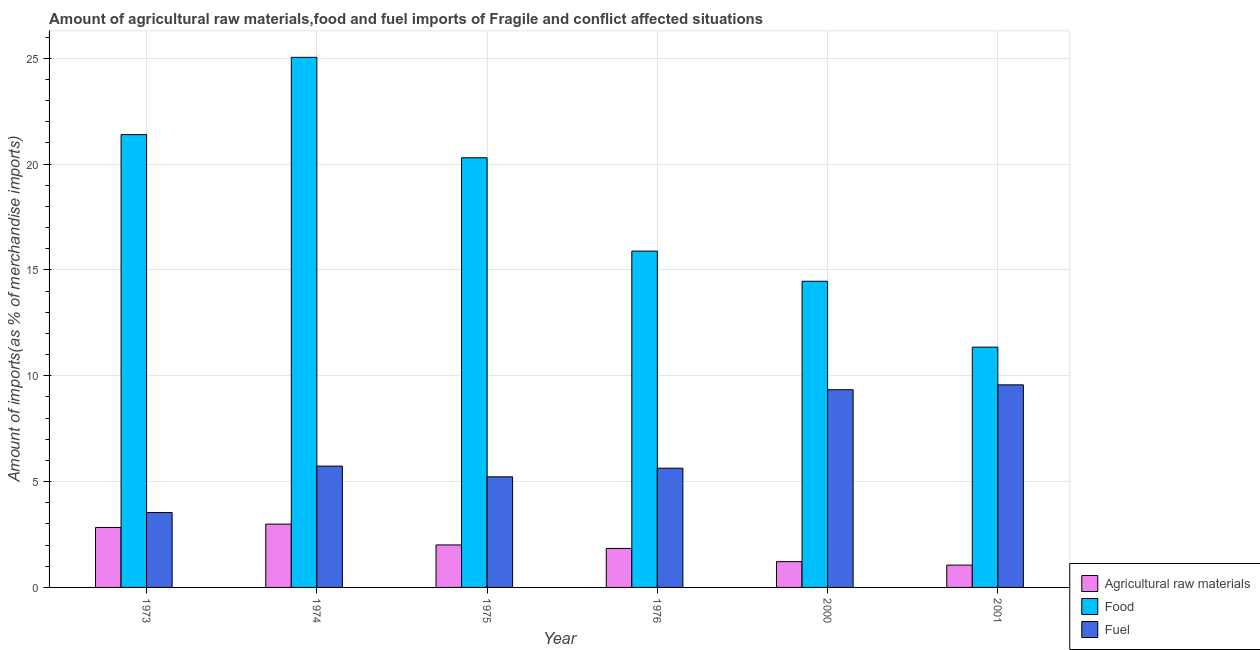Are the number of bars per tick equal to the number of legend labels?
Offer a terse response. Yes. How many bars are there on the 6th tick from the left?
Offer a very short reply. 3. How many bars are there on the 2nd tick from the right?
Your answer should be very brief. 3. What is the percentage of fuel imports in 1976?
Your answer should be compact. 5.63. Across all years, what is the maximum percentage of fuel imports?
Offer a terse response. 9.57. Across all years, what is the minimum percentage of food imports?
Offer a very short reply. 11.35. In which year was the percentage of food imports maximum?
Ensure brevity in your answer.  1974. What is the total percentage of raw materials imports in the graph?
Your answer should be very brief. 11.94. What is the difference between the percentage of fuel imports in 1976 and that in 2000?
Your response must be concise. -3.71. What is the difference between the percentage of food imports in 2000 and the percentage of raw materials imports in 1974?
Give a very brief answer. -10.58. What is the average percentage of food imports per year?
Offer a terse response. 18.07. In the year 1974, what is the difference between the percentage of fuel imports and percentage of food imports?
Keep it short and to the point. 0. In how many years, is the percentage of fuel imports greater than 13 %?
Provide a succinct answer. 0. What is the ratio of the percentage of fuel imports in 1974 to that in 2000?
Ensure brevity in your answer.  0.61. Is the percentage of fuel imports in 1976 less than that in 2000?
Offer a very short reply. Yes. Is the difference between the percentage of fuel imports in 1974 and 2000 greater than the difference between the percentage of raw materials imports in 1974 and 2000?
Ensure brevity in your answer.  No. What is the difference between the highest and the second highest percentage of raw materials imports?
Offer a very short reply. 0.16. What is the difference between the highest and the lowest percentage of raw materials imports?
Provide a succinct answer. 1.94. Is the sum of the percentage of food imports in 1973 and 1976 greater than the maximum percentage of fuel imports across all years?
Offer a terse response. Yes. What does the 1st bar from the left in 1975 represents?
Give a very brief answer. Agricultural raw materials. What does the 1st bar from the right in 1974 represents?
Your response must be concise. Fuel. How many bars are there?
Your answer should be very brief. 18. How many years are there in the graph?
Your answer should be compact. 6. What is the difference between two consecutive major ticks on the Y-axis?
Offer a very short reply. 5. Are the values on the major ticks of Y-axis written in scientific E-notation?
Your answer should be very brief. No. Does the graph contain grids?
Ensure brevity in your answer.  Yes. Where does the legend appear in the graph?
Give a very brief answer. Bottom right. How many legend labels are there?
Provide a succinct answer. 3. How are the legend labels stacked?
Give a very brief answer. Vertical. What is the title of the graph?
Provide a succinct answer. Amount of agricultural raw materials,food and fuel imports of Fragile and conflict affected situations. What is the label or title of the X-axis?
Give a very brief answer. Year. What is the label or title of the Y-axis?
Provide a succinct answer. Amount of imports(as % of merchandise imports). What is the Amount of imports(as % of merchandise imports) in Agricultural raw materials in 1973?
Ensure brevity in your answer.  2.83. What is the Amount of imports(as % of merchandise imports) in Food in 1973?
Give a very brief answer. 21.39. What is the Amount of imports(as % of merchandise imports) in Fuel in 1973?
Give a very brief answer. 3.54. What is the Amount of imports(as % of merchandise imports) in Agricultural raw materials in 1974?
Your response must be concise. 2.99. What is the Amount of imports(as % of merchandise imports) in Food in 1974?
Your response must be concise. 25.04. What is the Amount of imports(as % of merchandise imports) in Fuel in 1974?
Keep it short and to the point. 5.73. What is the Amount of imports(as % of merchandise imports) in Agricultural raw materials in 1975?
Offer a very short reply. 2.01. What is the Amount of imports(as % of merchandise imports) in Food in 1975?
Offer a very short reply. 20.3. What is the Amount of imports(as % of merchandise imports) in Fuel in 1975?
Offer a terse response. 5.22. What is the Amount of imports(as % of merchandise imports) of Agricultural raw materials in 1976?
Offer a terse response. 1.84. What is the Amount of imports(as % of merchandise imports) in Food in 1976?
Offer a very short reply. 15.89. What is the Amount of imports(as % of merchandise imports) of Fuel in 1976?
Provide a succinct answer. 5.63. What is the Amount of imports(as % of merchandise imports) in Agricultural raw materials in 2000?
Your answer should be compact. 1.22. What is the Amount of imports(as % of merchandise imports) of Food in 2000?
Make the answer very short. 14.46. What is the Amount of imports(as % of merchandise imports) in Fuel in 2000?
Offer a terse response. 9.34. What is the Amount of imports(as % of merchandise imports) of Agricultural raw materials in 2001?
Give a very brief answer. 1.05. What is the Amount of imports(as % of merchandise imports) in Food in 2001?
Keep it short and to the point. 11.35. What is the Amount of imports(as % of merchandise imports) in Fuel in 2001?
Provide a short and direct response. 9.57. Across all years, what is the maximum Amount of imports(as % of merchandise imports) of Agricultural raw materials?
Your answer should be compact. 2.99. Across all years, what is the maximum Amount of imports(as % of merchandise imports) of Food?
Give a very brief answer. 25.04. Across all years, what is the maximum Amount of imports(as % of merchandise imports) of Fuel?
Your answer should be compact. 9.57. Across all years, what is the minimum Amount of imports(as % of merchandise imports) in Agricultural raw materials?
Provide a short and direct response. 1.05. Across all years, what is the minimum Amount of imports(as % of merchandise imports) of Food?
Keep it short and to the point. 11.35. Across all years, what is the minimum Amount of imports(as % of merchandise imports) in Fuel?
Provide a short and direct response. 3.54. What is the total Amount of imports(as % of merchandise imports) of Agricultural raw materials in the graph?
Your answer should be compact. 11.94. What is the total Amount of imports(as % of merchandise imports) in Food in the graph?
Your answer should be very brief. 108.43. What is the total Amount of imports(as % of merchandise imports) in Fuel in the graph?
Make the answer very short. 39.04. What is the difference between the Amount of imports(as % of merchandise imports) of Agricultural raw materials in 1973 and that in 1974?
Provide a succinct answer. -0.16. What is the difference between the Amount of imports(as % of merchandise imports) of Food in 1973 and that in 1974?
Provide a short and direct response. -3.65. What is the difference between the Amount of imports(as % of merchandise imports) in Fuel in 1973 and that in 1974?
Keep it short and to the point. -2.19. What is the difference between the Amount of imports(as % of merchandise imports) of Agricultural raw materials in 1973 and that in 1975?
Your response must be concise. 0.83. What is the difference between the Amount of imports(as % of merchandise imports) of Food in 1973 and that in 1975?
Make the answer very short. 1.09. What is the difference between the Amount of imports(as % of merchandise imports) in Fuel in 1973 and that in 1975?
Your response must be concise. -1.69. What is the difference between the Amount of imports(as % of merchandise imports) in Food in 1973 and that in 1976?
Offer a terse response. 5.5. What is the difference between the Amount of imports(as % of merchandise imports) in Fuel in 1973 and that in 1976?
Offer a terse response. -2.09. What is the difference between the Amount of imports(as % of merchandise imports) of Agricultural raw materials in 1973 and that in 2000?
Your response must be concise. 1.62. What is the difference between the Amount of imports(as % of merchandise imports) in Food in 1973 and that in 2000?
Provide a short and direct response. 6.93. What is the difference between the Amount of imports(as % of merchandise imports) in Fuel in 1973 and that in 2000?
Offer a terse response. -5.8. What is the difference between the Amount of imports(as % of merchandise imports) of Agricultural raw materials in 1973 and that in 2001?
Provide a succinct answer. 1.78. What is the difference between the Amount of imports(as % of merchandise imports) of Food in 1973 and that in 2001?
Keep it short and to the point. 10.04. What is the difference between the Amount of imports(as % of merchandise imports) in Fuel in 1973 and that in 2001?
Ensure brevity in your answer.  -6.03. What is the difference between the Amount of imports(as % of merchandise imports) in Food in 1974 and that in 1975?
Offer a terse response. 4.74. What is the difference between the Amount of imports(as % of merchandise imports) of Fuel in 1974 and that in 1975?
Your response must be concise. 0.51. What is the difference between the Amount of imports(as % of merchandise imports) in Agricultural raw materials in 1974 and that in 1976?
Provide a short and direct response. 1.15. What is the difference between the Amount of imports(as % of merchandise imports) of Food in 1974 and that in 1976?
Make the answer very short. 9.15. What is the difference between the Amount of imports(as % of merchandise imports) of Fuel in 1974 and that in 1976?
Your response must be concise. 0.1. What is the difference between the Amount of imports(as % of merchandise imports) in Agricultural raw materials in 1974 and that in 2000?
Provide a short and direct response. 1.77. What is the difference between the Amount of imports(as % of merchandise imports) of Food in 1974 and that in 2000?
Keep it short and to the point. 10.58. What is the difference between the Amount of imports(as % of merchandise imports) of Fuel in 1974 and that in 2000?
Your answer should be very brief. -3.61. What is the difference between the Amount of imports(as % of merchandise imports) of Agricultural raw materials in 1974 and that in 2001?
Provide a succinct answer. 1.94. What is the difference between the Amount of imports(as % of merchandise imports) in Food in 1974 and that in 2001?
Provide a succinct answer. 13.69. What is the difference between the Amount of imports(as % of merchandise imports) in Fuel in 1974 and that in 2001?
Make the answer very short. -3.84. What is the difference between the Amount of imports(as % of merchandise imports) of Agricultural raw materials in 1975 and that in 1976?
Provide a succinct answer. 0.17. What is the difference between the Amount of imports(as % of merchandise imports) of Food in 1975 and that in 1976?
Offer a terse response. 4.41. What is the difference between the Amount of imports(as % of merchandise imports) of Fuel in 1975 and that in 1976?
Provide a short and direct response. -0.41. What is the difference between the Amount of imports(as % of merchandise imports) in Agricultural raw materials in 1975 and that in 2000?
Your response must be concise. 0.79. What is the difference between the Amount of imports(as % of merchandise imports) of Food in 1975 and that in 2000?
Keep it short and to the point. 5.83. What is the difference between the Amount of imports(as % of merchandise imports) of Fuel in 1975 and that in 2000?
Your response must be concise. -4.12. What is the difference between the Amount of imports(as % of merchandise imports) in Agricultural raw materials in 1975 and that in 2001?
Give a very brief answer. 0.95. What is the difference between the Amount of imports(as % of merchandise imports) of Food in 1975 and that in 2001?
Provide a short and direct response. 8.95. What is the difference between the Amount of imports(as % of merchandise imports) in Fuel in 1975 and that in 2001?
Offer a very short reply. -4.35. What is the difference between the Amount of imports(as % of merchandise imports) in Agricultural raw materials in 1976 and that in 2000?
Keep it short and to the point. 0.62. What is the difference between the Amount of imports(as % of merchandise imports) in Food in 1976 and that in 2000?
Offer a terse response. 1.43. What is the difference between the Amount of imports(as % of merchandise imports) of Fuel in 1976 and that in 2000?
Your answer should be compact. -3.71. What is the difference between the Amount of imports(as % of merchandise imports) in Agricultural raw materials in 1976 and that in 2001?
Offer a terse response. 0.79. What is the difference between the Amount of imports(as % of merchandise imports) of Food in 1976 and that in 2001?
Offer a very short reply. 4.54. What is the difference between the Amount of imports(as % of merchandise imports) in Fuel in 1976 and that in 2001?
Provide a succinct answer. -3.94. What is the difference between the Amount of imports(as % of merchandise imports) of Agricultural raw materials in 2000 and that in 2001?
Provide a short and direct response. 0.16. What is the difference between the Amount of imports(as % of merchandise imports) in Food in 2000 and that in 2001?
Your answer should be compact. 3.11. What is the difference between the Amount of imports(as % of merchandise imports) of Fuel in 2000 and that in 2001?
Provide a short and direct response. -0.23. What is the difference between the Amount of imports(as % of merchandise imports) in Agricultural raw materials in 1973 and the Amount of imports(as % of merchandise imports) in Food in 1974?
Your answer should be compact. -22.21. What is the difference between the Amount of imports(as % of merchandise imports) of Agricultural raw materials in 1973 and the Amount of imports(as % of merchandise imports) of Fuel in 1974?
Keep it short and to the point. -2.9. What is the difference between the Amount of imports(as % of merchandise imports) in Food in 1973 and the Amount of imports(as % of merchandise imports) in Fuel in 1974?
Provide a succinct answer. 15.66. What is the difference between the Amount of imports(as % of merchandise imports) in Agricultural raw materials in 1973 and the Amount of imports(as % of merchandise imports) in Food in 1975?
Give a very brief answer. -17.46. What is the difference between the Amount of imports(as % of merchandise imports) in Agricultural raw materials in 1973 and the Amount of imports(as % of merchandise imports) in Fuel in 1975?
Your answer should be very brief. -2.39. What is the difference between the Amount of imports(as % of merchandise imports) of Food in 1973 and the Amount of imports(as % of merchandise imports) of Fuel in 1975?
Keep it short and to the point. 16.17. What is the difference between the Amount of imports(as % of merchandise imports) in Agricultural raw materials in 1973 and the Amount of imports(as % of merchandise imports) in Food in 1976?
Your response must be concise. -13.05. What is the difference between the Amount of imports(as % of merchandise imports) in Agricultural raw materials in 1973 and the Amount of imports(as % of merchandise imports) in Fuel in 1976?
Offer a terse response. -2.8. What is the difference between the Amount of imports(as % of merchandise imports) of Food in 1973 and the Amount of imports(as % of merchandise imports) of Fuel in 1976?
Your answer should be very brief. 15.76. What is the difference between the Amount of imports(as % of merchandise imports) of Agricultural raw materials in 1973 and the Amount of imports(as % of merchandise imports) of Food in 2000?
Your answer should be compact. -11.63. What is the difference between the Amount of imports(as % of merchandise imports) in Agricultural raw materials in 1973 and the Amount of imports(as % of merchandise imports) in Fuel in 2000?
Give a very brief answer. -6.51. What is the difference between the Amount of imports(as % of merchandise imports) in Food in 1973 and the Amount of imports(as % of merchandise imports) in Fuel in 2000?
Your response must be concise. 12.05. What is the difference between the Amount of imports(as % of merchandise imports) in Agricultural raw materials in 1973 and the Amount of imports(as % of merchandise imports) in Food in 2001?
Your answer should be compact. -8.52. What is the difference between the Amount of imports(as % of merchandise imports) of Agricultural raw materials in 1973 and the Amount of imports(as % of merchandise imports) of Fuel in 2001?
Offer a very short reply. -6.74. What is the difference between the Amount of imports(as % of merchandise imports) of Food in 1973 and the Amount of imports(as % of merchandise imports) of Fuel in 2001?
Provide a succinct answer. 11.82. What is the difference between the Amount of imports(as % of merchandise imports) in Agricultural raw materials in 1974 and the Amount of imports(as % of merchandise imports) in Food in 1975?
Provide a short and direct response. -17.31. What is the difference between the Amount of imports(as % of merchandise imports) of Agricultural raw materials in 1974 and the Amount of imports(as % of merchandise imports) of Fuel in 1975?
Offer a terse response. -2.23. What is the difference between the Amount of imports(as % of merchandise imports) of Food in 1974 and the Amount of imports(as % of merchandise imports) of Fuel in 1975?
Make the answer very short. 19.82. What is the difference between the Amount of imports(as % of merchandise imports) in Agricultural raw materials in 1974 and the Amount of imports(as % of merchandise imports) in Food in 1976?
Your answer should be compact. -12.9. What is the difference between the Amount of imports(as % of merchandise imports) of Agricultural raw materials in 1974 and the Amount of imports(as % of merchandise imports) of Fuel in 1976?
Offer a very short reply. -2.64. What is the difference between the Amount of imports(as % of merchandise imports) of Food in 1974 and the Amount of imports(as % of merchandise imports) of Fuel in 1976?
Provide a succinct answer. 19.41. What is the difference between the Amount of imports(as % of merchandise imports) in Agricultural raw materials in 1974 and the Amount of imports(as % of merchandise imports) in Food in 2000?
Provide a succinct answer. -11.47. What is the difference between the Amount of imports(as % of merchandise imports) in Agricultural raw materials in 1974 and the Amount of imports(as % of merchandise imports) in Fuel in 2000?
Ensure brevity in your answer.  -6.35. What is the difference between the Amount of imports(as % of merchandise imports) of Food in 1974 and the Amount of imports(as % of merchandise imports) of Fuel in 2000?
Ensure brevity in your answer.  15.7. What is the difference between the Amount of imports(as % of merchandise imports) of Agricultural raw materials in 1974 and the Amount of imports(as % of merchandise imports) of Food in 2001?
Keep it short and to the point. -8.36. What is the difference between the Amount of imports(as % of merchandise imports) of Agricultural raw materials in 1974 and the Amount of imports(as % of merchandise imports) of Fuel in 2001?
Ensure brevity in your answer.  -6.58. What is the difference between the Amount of imports(as % of merchandise imports) of Food in 1974 and the Amount of imports(as % of merchandise imports) of Fuel in 2001?
Offer a very short reply. 15.47. What is the difference between the Amount of imports(as % of merchandise imports) in Agricultural raw materials in 1975 and the Amount of imports(as % of merchandise imports) in Food in 1976?
Provide a short and direct response. -13.88. What is the difference between the Amount of imports(as % of merchandise imports) of Agricultural raw materials in 1975 and the Amount of imports(as % of merchandise imports) of Fuel in 1976?
Your answer should be compact. -3.63. What is the difference between the Amount of imports(as % of merchandise imports) in Food in 1975 and the Amount of imports(as % of merchandise imports) in Fuel in 1976?
Offer a terse response. 14.66. What is the difference between the Amount of imports(as % of merchandise imports) in Agricultural raw materials in 1975 and the Amount of imports(as % of merchandise imports) in Food in 2000?
Ensure brevity in your answer.  -12.45. What is the difference between the Amount of imports(as % of merchandise imports) in Agricultural raw materials in 1975 and the Amount of imports(as % of merchandise imports) in Fuel in 2000?
Make the answer very short. -7.33. What is the difference between the Amount of imports(as % of merchandise imports) of Food in 1975 and the Amount of imports(as % of merchandise imports) of Fuel in 2000?
Keep it short and to the point. 10.96. What is the difference between the Amount of imports(as % of merchandise imports) of Agricultural raw materials in 1975 and the Amount of imports(as % of merchandise imports) of Food in 2001?
Ensure brevity in your answer.  -9.34. What is the difference between the Amount of imports(as % of merchandise imports) in Agricultural raw materials in 1975 and the Amount of imports(as % of merchandise imports) in Fuel in 2001?
Provide a short and direct response. -7.56. What is the difference between the Amount of imports(as % of merchandise imports) in Food in 1975 and the Amount of imports(as % of merchandise imports) in Fuel in 2001?
Make the answer very short. 10.73. What is the difference between the Amount of imports(as % of merchandise imports) in Agricultural raw materials in 1976 and the Amount of imports(as % of merchandise imports) in Food in 2000?
Provide a succinct answer. -12.62. What is the difference between the Amount of imports(as % of merchandise imports) in Agricultural raw materials in 1976 and the Amount of imports(as % of merchandise imports) in Fuel in 2000?
Offer a terse response. -7.5. What is the difference between the Amount of imports(as % of merchandise imports) in Food in 1976 and the Amount of imports(as % of merchandise imports) in Fuel in 2000?
Keep it short and to the point. 6.55. What is the difference between the Amount of imports(as % of merchandise imports) in Agricultural raw materials in 1976 and the Amount of imports(as % of merchandise imports) in Food in 2001?
Ensure brevity in your answer.  -9.51. What is the difference between the Amount of imports(as % of merchandise imports) in Agricultural raw materials in 1976 and the Amount of imports(as % of merchandise imports) in Fuel in 2001?
Keep it short and to the point. -7.73. What is the difference between the Amount of imports(as % of merchandise imports) of Food in 1976 and the Amount of imports(as % of merchandise imports) of Fuel in 2001?
Your answer should be very brief. 6.32. What is the difference between the Amount of imports(as % of merchandise imports) of Agricultural raw materials in 2000 and the Amount of imports(as % of merchandise imports) of Food in 2001?
Offer a very short reply. -10.13. What is the difference between the Amount of imports(as % of merchandise imports) of Agricultural raw materials in 2000 and the Amount of imports(as % of merchandise imports) of Fuel in 2001?
Offer a very short reply. -8.35. What is the difference between the Amount of imports(as % of merchandise imports) of Food in 2000 and the Amount of imports(as % of merchandise imports) of Fuel in 2001?
Your answer should be very brief. 4.89. What is the average Amount of imports(as % of merchandise imports) of Agricultural raw materials per year?
Your response must be concise. 1.99. What is the average Amount of imports(as % of merchandise imports) in Food per year?
Your response must be concise. 18.07. What is the average Amount of imports(as % of merchandise imports) of Fuel per year?
Make the answer very short. 6.51. In the year 1973, what is the difference between the Amount of imports(as % of merchandise imports) of Agricultural raw materials and Amount of imports(as % of merchandise imports) of Food?
Provide a succinct answer. -18.56. In the year 1973, what is the difference between the Amount of imports(as % of merchandise imports) of Agricultural raw materials and Amount of imports(as % of merchandise imports) of Fuel?
Offer a very short reply. -0.71. In the year 1973, what is the difference between the Amount of imports(as % of merchandise imports) in Food and Amount of imports(as % of merchandise imports) in Fuel?
Offer a very short reply. 17.85. In the year 1974, what is the difference between the Amount of imports(as % of merchandise imports) of Agricultural raw materials and Amount of imports(as % of merchandise imports) of Food?
Your response must be concise. -22.05. In the year 1974, what is the difference between the Amount of imports(as % of merchandise imports) in Agricultural raw materials and Amount of imports(as % of merchandise imports) in Fuel?
Your answer should be compact. -2.74. In the year 1974, what is the difference between the Amount of imports(as % of merchandise imports) of Food and Amount of imports(as % of merchandise imports) of Fuel?
Keep it short and to the point. 19.31. In the year 1975, what is the difference between the Amount of imports(as % of merchandise imports) of Agricultural raw materials and Amount of imports(as % of merchandise imports) of Food?
Give a very brief answer. -18.29. In the year 1975, what is the difference between the Amount of imports(as % of merchandise imports) of Agricultural raw materials and Amount of imports(as % of merchandise imports) of Fuel?
Provide a succinct answer. -3.22. In the year 1975, what is the difference between the Amount of imports(as % of merchandise imports) in Food and Amount of imports(as % of merchandise imports) in Fuel?
Offer a very short reply. 15.07. In the year 1976, what is the difference between the Amount of imports(as % of merchandise imports) in Agricultural raw materials and Amount of imports(as % of merchandise imports) in Food?
Your response must be concise. -14.05. In the year 1976, what is the difference between the Amount of imports(as % of merchandise imports) in Agricultural raw materials and Amount of imports(as % of merchandise imports) in Fuel?
Offer a very short reply. -3.79. In the year 1976, what is the difference between the Amount of imports(as % of merchandise imports) in Food and Amount of imports(as % of merchandise imports) in Fuel?
Your answer should be compact. 10.25. In the year 2000, what is the difference between the Amount of imports(as % of merchandise imports) of Agricultural raw materials and Amount of imports(as % of merchandise imports) of Food?
Your answer should be compact. -13.24. In the year 2000, what is the difference between the Amount of imports(as % of merchandise imports) in Agricultural raw materials and Amount of imports(as % of merchandise imports) in Fuel?
Give a very brief answer. -8.12. In the year 2000, what is the difference between the Amount of imports(as % of merchandise imports) in Food and Amount of imports(as % of merchandise imports) in Fuel?
Provide a succinct answer. 5.12. In the year 2001, what is the difference between the Amount of imports(as % of merchandise imports) in Agricultural raw materials and Amount of imports(as % of merchandise imports) in Food?
Ensure brevity in your answer.  -10.3. In the year 2001, what is the difference between the Amount of imports(as % of merchandise imports) in Agricultural raw materials and Amount of imports(as % of merchandise imports) in Fuel?
Offer a terse response. -8.52. In the year 2001, what is the difference between the Amount of imports(as % of merchandise imports) in Food and Amount of imports(as % of merchandise imports) in Fuel?
Make the answer very short. 1.78. What is the ratio of the Amount of imports(as % of merchandise imports) of Agricultural raw materials in 1973 to that in 1974?
Your answer should be very brief. 0.95. What is the ratio of the Amount of imports(as % of merchandise imports) in Food in 1973 to that in 1974?
Provide a succinct answer. 0.85. What is the ratio of the Amount of imports(as % of merchandise imports) in Fuel in 1973 to that in 1974?
Provide a short and direct response. 0.62. What is the ratio of the Amount of imports(as % of merchandise imports) in Agricultural raw materials in 1973 to that in 1975?
Your response must be concise. 1.41. What is the ratio of the Amount of imports(as % of merchandise imports) in Food in 1973 to that in 1975?
Give a very brief answer. 1.05. What is the ratio of the Amount of imports(as % of merchandise imports) of Fuel in 1973 to that in 1975?
Provide a succinct answer. 0.68. What is the ratio of the Amount of imports(as % of merchandise imports) of Agricultural raw materials in 1973 to that in 1976?
Offer a very short reply. 1.54. What is the ratio of the Amount of imports(as % of merchandise imports) in Food in 1973 to that in 1976?
Offer a very short reply. 1.35. What is the ratio of the Amount of imports(as % of merchandise imports) in Fuel in 1973 to that in 1976?
Your answer should be very brief. 0.63. What is the ratio of the Amount of imports(as % of merchandise imports) of Agricultural raw materials in 1973 to that in 2000?
Keep it short and to the point. 2.33. What is the ratio of the Amount of imports(as % of merchandise imports) in Food in 1973 to that in 2000?
Your answer should be compact. 1.48. What is the ratio of the Amount of imports(as % of merchandise imports) of Fuel in 1973 to that in 2000?
Provide a succinct answer. 0.38. What is the ratio of the Amount of imports(as % of merchandise imports) in Agricultural raw materials in 1973 to that in 2001?
Make the answer very short. 2.69. What is the ratio of the Amount of imports(as % of merchandise imports) of Food in 1973 to that in 2001?
Keep it short and to the point. 1.88. What is the ratio of the Amount of imports(as % of merchandise imports) of Fuel in 1973 to that in 2001?
Make the answer very short. 0.37. What is the ratio of the Amount of imports(as % of merchandise imports) in Agricultural raw materials in 1974 to that in 1975?
Your answer should be very brief. 1.49. What is the ratio of the Amount of imports(as % of merchandise imports) in Food in 1974 to that in 1975?
Offer a terse response. 1.23. What is the ratio of the Amount of imports(as % of merchandise imports) in Fuel in 1974 to that in 1975?
Your answer should be compact. 1.1. What is the ratio of the Amount of imports(as % of merchandise imports) in Agricultural raw materials in 1974 to that in 1976?
Make the answer very short. 1.62. What is the ratio of the Amount of imports(as % of merchandise imports) in Food in 1974 to that in 1976?
Provide a short and direct response. 1.58. What is the ratio of the Amount of imports(as % of merchandise imports) in Fuel in 1974 to that in 1976?
Keep it short and to the point. 1.02. What is the ratio of the Amount of imports(as % of merchandise imports) in Agricultural raw materials in 1974 to that in 2000?
Keep it short and to the point. 2.45. What is the ratio of the Amount of imports(as % of merchandise imports) in Food in 1974 to that in 2000?
Offer a terse response. 1.73. What is the ratio of the Amount of imports(as % of merchandise imports) in Fuel in 1974 to that in 2000?
Give a very brief answer. 0.61. What is the ratio of the Amount of imports(as % of merchandise imports) of Agricultural raw materials in 1974 to that in 2001?
Provide a succinct answer. 2.84. What is the ratio of the Amount of imports(as % of merchandise imports) of Food in 1974 to that in 2001?
Your answer should be very brief. 2.21. What is the ratio of the Amount of imports(as % of merchandise imports) of Fuel in 1974 to that in 2001?
Offer a very short reply. 0.6. What is the ratio of the Amount of imports(as % of merchandise imports) in Agricultural raw materials in 1975 to that in 1976?
Give a very brief answer. 1.09. What is the ratio of the Amount of imports(as % of merchandise imports) of Food in 1975 to that in 1976?
Offer a very short reply. 1.28. What is the ratio of the Amount of imports(as % of merchandise imports) of Fuel in 1975 to that in 1976?
Offer a very short reply. 0.93. What is the ratio of the Amount of imports(as % of merchandise imports) in Agricultural raw materials in 1975 to that in 2000?
Ensure brevity in your answer.  1.65. What is the ratio of the Amount of imports(as % of merchandise imports) of Food in 1975 to that in 2000?
Offer a very short reply. 1.4. What is the ratio of the Amount of imports(as % of merchandise imports) in Fuel in 1975 to that in 2000?
Your answer should be compact. 0.56. What is the ratio of the Amount of imports(as % of merchandise imports) in Agricultural raw materials in 1975 to that in 2001?
Provide a succinct answer. 1.91. What is the ratio of the Amount of imports(as % of merchandise imports) in Food in 1975 to that in 2001?
Provide a succinct answer. 1.79. What is the ratio of the Amount of imports(as % of merchandise imports) in Fuel in 1975 to that in 2001?
Keep it short and to the point. 0.55. What is the ratio of the Amount of imports(as % of merchandise imports) of Agricultural raw materials in 1976 to that in 2000?
Offer a terse response. 1.51. What is the ratio of the Amount of imports(as % of merchandise imports) of Food in 1976 to that in 2000?
Provide a succinct answer. 1.1. What is the ratio of the Amount of imports(as % of merchandise imports) in Fuel in 1976 to that in 2000?
Make the answer very short. 0.6. What is the ratio of the Amount of imports(as % of merchandise imports) of Agricultural raw materials in 1976 to that in 2001?
Provide a succinct answer. 1.75. What is the ratio of the Amount of imports(as % of merchandise imports) of Food in 1976 to that in 2001?
Make the answer very short. 1.4. What is the ratio of the Amount of imports(as % of merchandise imports) of Fuel in 1976 to that in 2001?
Keep it short and to the point. 0.59. What is the ratio of the Amount of imports(as % of merchandise imports) of Agricultural raw materials in 2000 to that in 2001?
Ensure brevity in your answer.  1.16. What is the ratio of the Amount of imports(as % of merchandise imports) of Food in 2000 to that in 2001?
Keep it short and to the point. 1.27. What is the difference between the highest and the second highest Amount of imports(as % of merchandise imports) of Agricultural raw materials?
Offer a terse response. 0.16. What is the difference between the highest and the second highest Amount of imports(as % of merchandise imports) of Food?
Offer a terse response. 3.65. What is the difference between the highest and the second highest Amount of imports(as % of merchandise imports) of Fuel?
Your answer should be compact. 0.23. What is the difference between the highest and the lowest Amount of imports(as % of merchandise imports) in Agricultural raw materials?
Your answer should be very brief. 1.94. What is the difference between the highest and the lowest Amount of imports(as % of merchandise imports) in Food?
Your answer should be compact. 13.69. What is the difference between the highest and the lowest Amount of imports(as % of merchandise imports) of Fuel?
Your answer should be very brief. 6.03. 